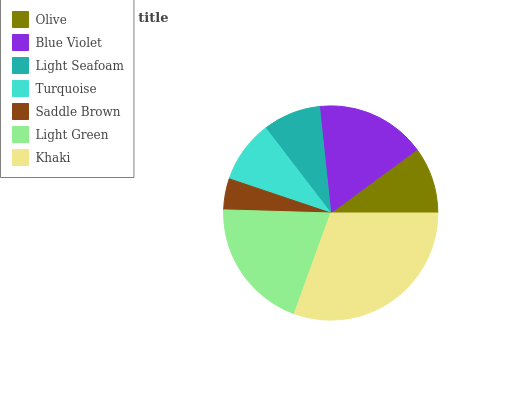Is Saddle Brown the minimum?
Answer yes or no. Yes. Is Khaki the maximum?
Answer yes or no. Yes. Is Blue Violet the minimum?
Answer yes or no. No. Is Blue Violet the maximum?
Answer yes or no. No. Is Blue Violet greater than Olive?
Answer yes or no. Yes. Is Olive less than Blue Violet?
Answer yes or no. Yes. Is Olive greater than Blue Violet?
Answer yes or no. No. Is Blue Violet less than Olive?
Answer yes or no. No. Is Olive the high median?
Answer yes or no. Yes. Is Olive the low median?
Answer yes or no. Yes. Is Turquoise the high median?
Answer yes or no. No. Is Light Green the low median?
Answer yes or no. No. 